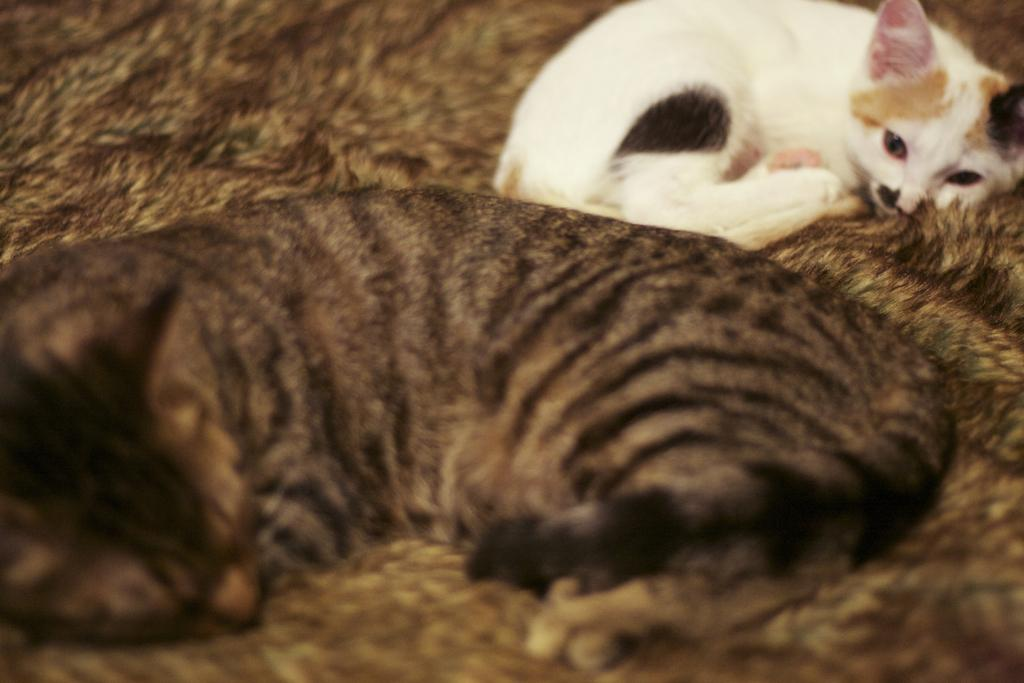How many cats are in the image? There are two cats in the image. What colors are the cats? The cats are black, brown, and white in color. What are the cats doing in the image? The cats are sleeping. What is the color of the floor in the image? The floor is brown and black in color. What type of agreement did the woman sign in the image? There is no woman or agreement present in the image; it features two cats sleeping on a brown and black floor. 